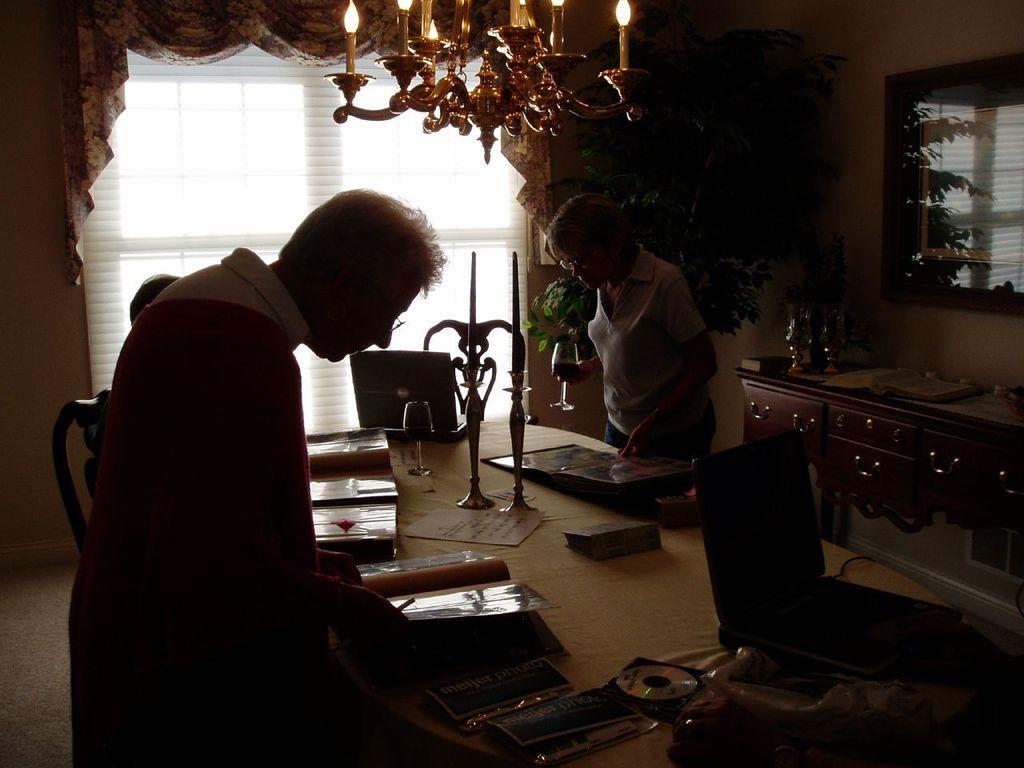Describe this image in one or two sentences. In this picture we can see a man and a woman standing on the floor. She is holding a glass with her hand. This is table. On the table there is a laptop, glass, books, and papers. And on the background there is a window and this is curtain. Here we can see candles. And this is plant. 